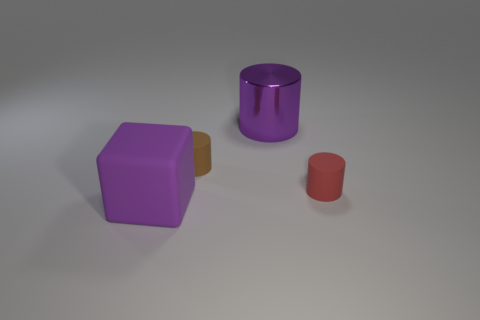Subtract all purple cylinders. How many cylinders are left? 2 Subtract 1 cylinders. How many cylinders are left? 2 Add 3 brown matte things. How many objects exist? 7 Add 3 cyan metallic cubes. How many cyan metallic cubes exist? 3 Subtract 0 gray cubes. How many objects are left? 4 Subtract all cylinders. How many objects are left? 1 Subtract all gray blocks. Subtract all cyan spheres. How many blocks are left? 1 Subtract all large purple objects. Subtract all purple matte things. How many objects are left? 1 Add 4 tiny brown cylinders. How many tiny brown cylinders are left? 5 